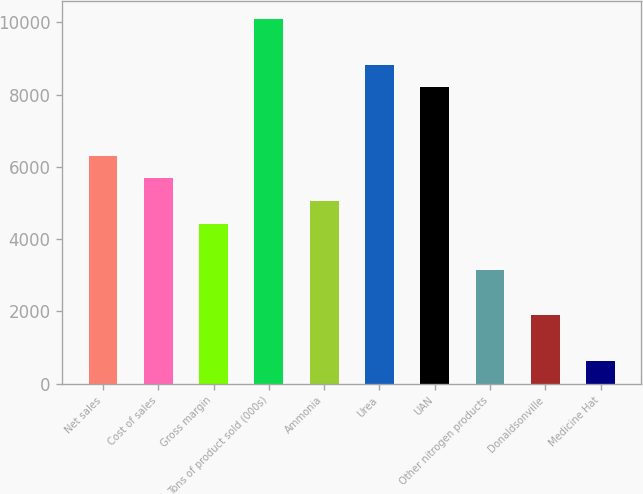Convert chart. <chart><loc_0><loc_0><loc_500><loc_500><bar_chart><fcel>Net sales<fcel>Cost of sales<fcel>Gross margin<fcel>Tons of product sold (000s)<fcel>Ammonia<fcel>Urea<fcel>UAN<fcel>Other nitrogen products<fcel>Donaldsonville<fcel>Medicine Hat<nl><fcel>6309.96<fcel>5679.54<fcel>4418.7<fcel>10092.5<fcel>5049.12<fcel>8831.64<fcel>8201.22<fcel>3157.86<fcel>1897.02<fcel>636.18<nl></chart> 